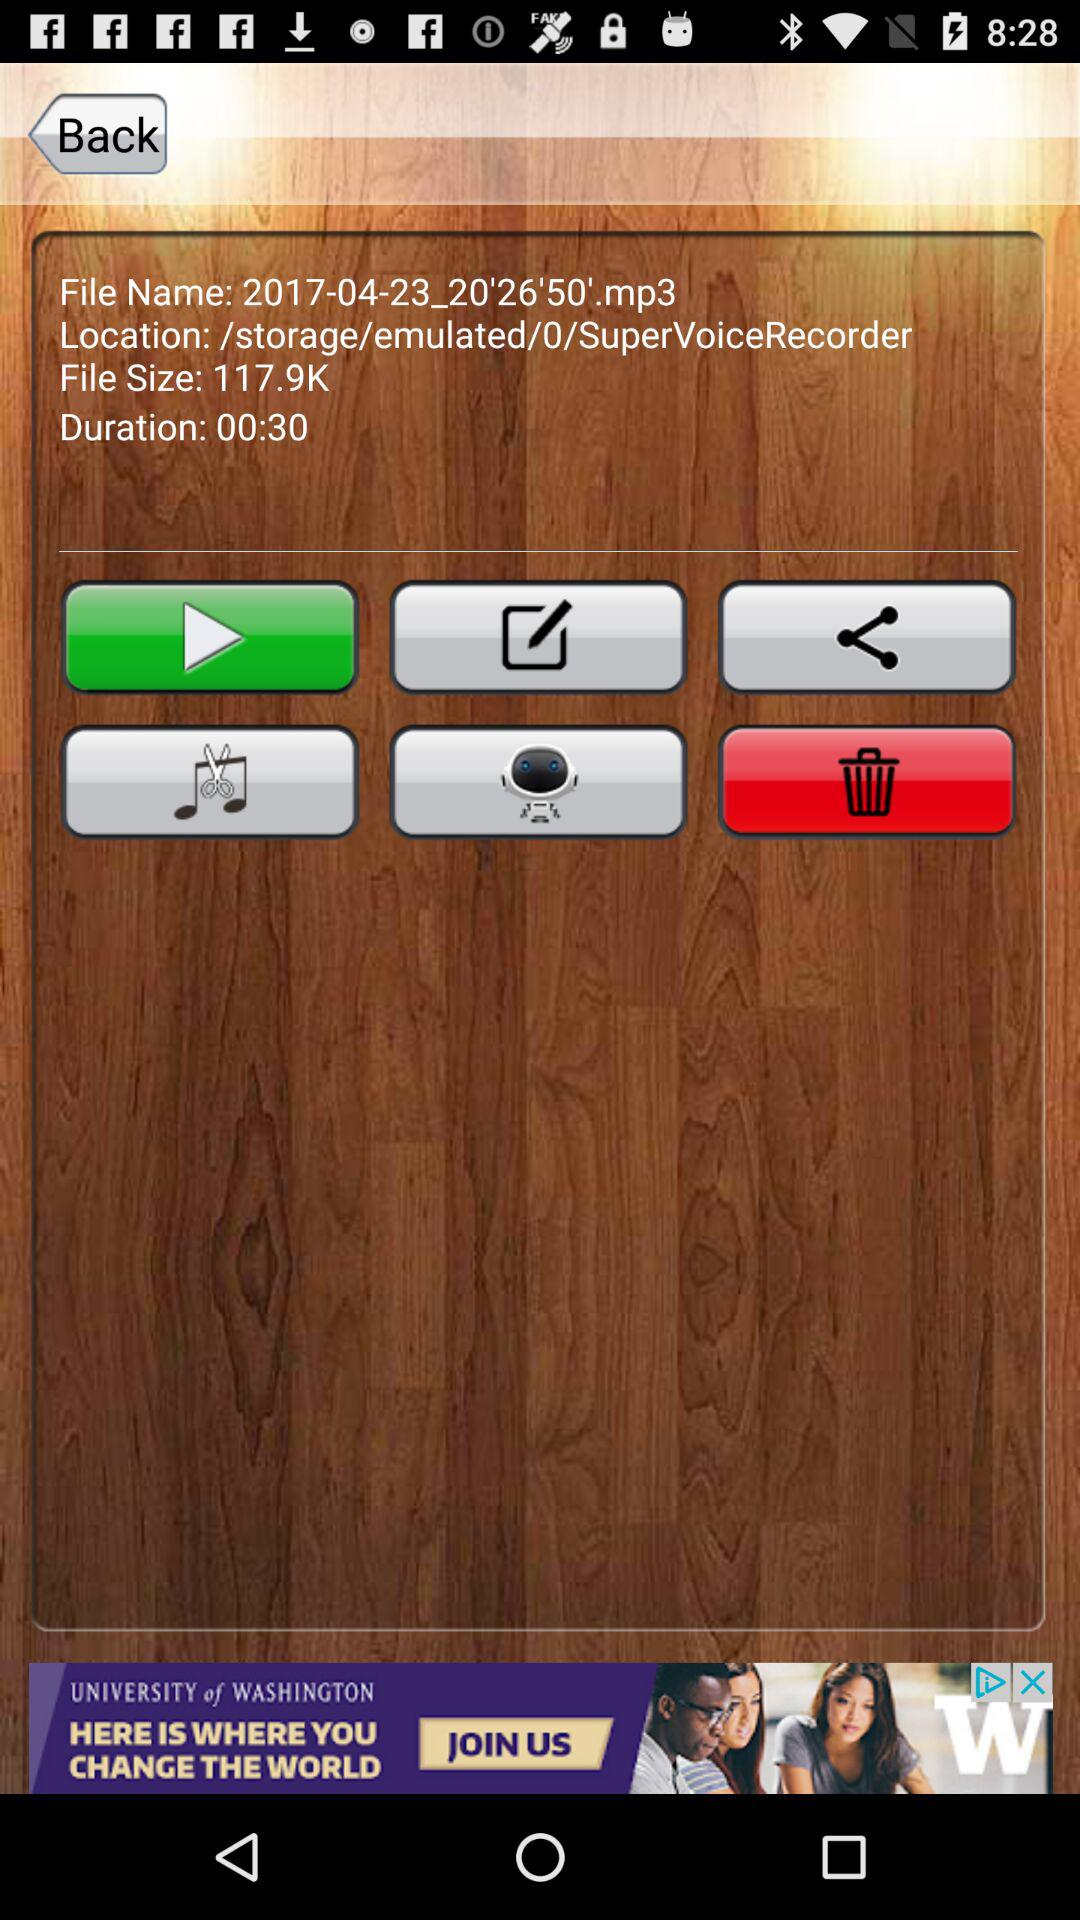What is the file name? The file name is "2017-04-23_20'26'50'.mp3". 